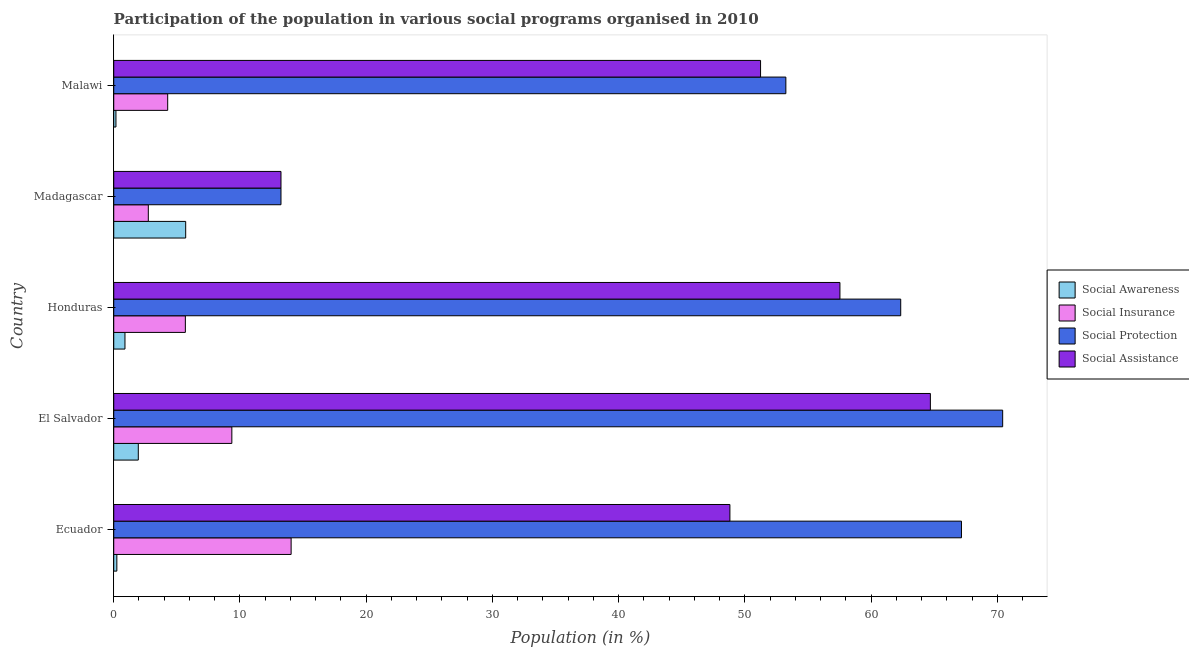How many different coloured bars are there?
Make the answer very short. 4. How many groups of bars are there?
Provide a succinct answer. 5. How many bars are there on the 5th tick from the top?
Offer a terse response. 4. How many bars are there on the 2nd tick from the bottom?
Make the answer very short. 4. What is the label of the 5th group of bars from the top?
Offer a terse response. Ecuador. What is the participation of population in social protection programs in Malawi?
Ensure brevity in your answer.  53.24. Across all countries, what is the maximum participation of population in social awareness programs?
Provide a short and direct response. 5.7. Across all countries, what is the minimum participation of population in social insurance programs?
Your response must be concise. 2.74. In which country was the participation of population in social awareness programs maximum?
Provide a short and direct response. Madagascar. In which country was the participation of population in social protection programs minimum?
Keep it short and to the point. Madagascar. What is the total participation of population in social protection programs in the graph?
Ensure brevity in your answer.  266.4. What is the difference between the participation of population in social protection programs in Ecuador and that in Madagascar?
Your response must be concise. 53.9. What is the difference between the participation of population in social awareness programs in Honduras and the participation of population in social insurance programs in El Salvador?
Your answer should be compact. -8.47. What is the average participation of population in social assistance programs per country?
Provide a succinct answer. 47.1. What is the difference between the participation of population in social awareness programs and participation of population in social protection programs in Malawi?
Offer a very short reply. -53.07. What is the ratio of the participation of population in social assistance programs in Ecuador to that in El Salvador?
Provide a succinct answer. 0.76. Is the difference between the participation of population in social awareness programs in Ecuador and Honduras greater than the difference between the participation of population in social protection programs in Ecuador and Honduras?
Your answer should be compact. No. What is the difference between the highest and the second highest participation of population in social protection programs?
Offer a very short reply. 3.26. What is the difference between the highest and the lowest participation of population in social awareness programs?
Your answer should be compact. 5.52. What does the 4th bar from the top in Honduras represents?
Keep it short and to the point. Social Awareness. What does the 1st bar from the bottom in Ecuador represents?
Provide a short and direct response. Social Awareness. Are all the bars in the graph horizontal?
Keep it short and to the point. Yes. How many countries are there in the graph?
Offer a very short reply. 5. Does the graph contain grids?
Your answer should be compact. No. Where does the legend appear in the graph?
Provide a succinct answer. Center right. How many legend labels are there?
Give a very brief answer. 4. What is the title of the graph?
Provide a short and direct response. Participation of the population in various social programs organised in 2010. Does "UNTA" appear as one of the legend labels in the graph?
Ensure brevity in your answer.  No. What is the label or title of the Y-axis?
Give a very brief answer. Country. What is the Population (in %) in Social Awareness in Ecuador?
Your answer should be compact. 0.25. What is the Population (in %) of Social Insurance in Ecuador?
Your answer should be compact. 14.05. What is the Population (in %) in Social Protection in Ecuador?
Make the answer very short. 67.15. What is the Population (in %) in Social Assistance in Ecuador?
Your response must be concise. 48.81. What is the Population (in %) of Social Awareness in El Salvador?
Your answer should be very brief. 1.95. What is the Population (in %) in Social Insurance in El Salvador?
Your answer should be compact. 9.35. What is the Population (in %) in Social Protection in El Salvador?
Provide a succinct answer. 70.42. What is the Population (in %) in Social Assistance in El Salvador?
Keep it short and to the point. 64.69. What is the Population (in %) of Social Awareness in Honduras?
Your response must be concise. 0.89. What is the Population (in %) in Social Insurance in Honduras?
Provide a short and direct response. 5.67. What is the Population (in %) in Social Protection in Honduras?
Provide a short and direct response. 62.34. What is the Population (in %) of Social Assistance in Honduras?
Your answer should be very brief. 57.53. What is the Population (in %) of Social Awareness in Madagascar?
Provide a short and direct response. 5.7. What is the Population (in %) in Social Insurance in Madagascar?
Ensure brevity in your answer.  2.74. What is the Population (in %) in Social Protection in Madagascar?
Your answer should be very brief. 13.25. What is the Population (in %) of Social Assistance in Madagascar?
Offer a very short reply. 13.25. What is the Population (in %) in Social Awareness in Malawi?
Keep it short and to the point. 0.18. What is the Population (in %) in Social Insurance in Malawi?
Offer a very short reply. 4.27. What is the Population (in %) in Social Protection in Malawi?
Make the answer very short. 53.24. What is the Population (in %) in Social Assistance in Malawi?
Give a very brief answer. 51.24. Across all countries, what is the maximum Population (in %) of Social Awareness?
Your answer should be compact. 5.7. Across all countries, what is the maximum Population (in %) in Social Insurance?
Give a very brief answer. 14.05. Across all countries, what is the maximum Population (in %) in Social Protection?
Your answer should be compact. 70.42. Across all countries, what is the maximum Population (in %) of Social Assistance?
Your answer should be compact. 64.69. Across all countries, what is the minimum Population (in %) in Social Awareness?
Offer a terse response. 0.18. Across all countries, what is the minimum Population (in %) in Social Insurance?
Make the answer very short. 2.74. Across all countries, what is the minimum Population (in %) in Social Protection?
Make the answer very short. 13.25. Across all countries, what is the minimum Population (in %) in Social Assistance?
Keep it short and to the point. 13.25. What is the total Population (in %) of Social Awareness in the graph?
Ensure brevity in your answer.  8.95. What is the total Population (in %) in Social Insurance in the graph?
Give a very brief answer. 36.09. What is the total Population (in %) in Social Protection in the graph?
Your answer should be compact. 266.4. What is the total Population (in %) in Social Assistance in the graph?
Offer a very short reply. 235.51. What is the difference between the Population (in %) in Social Awareness in Ecuador and that in El Salvador?
Make the answer very short. -1.7. What is the difference between the Population (in %) of Social Insurance in Ecuador and that in El Salvador?
Keep it short and to the point. 4.7. What is the difference between the Population (in %) of Social Protection in Ecuador and that in El Salvador?
Your answer should be compact. -3.26. What is the difference between the Population (in %) in Social Assistance in Ecuador and that in El Salvador?
Give a very brief answer. -15.88. What is the difference between the Population (in %) of Social Awareness in Ecuador and that in Honduras?
Offer a very short reply. -0.64. What is the difference between the Population (in %) in Social Insurance in Ecuador and that in Honduras?
Make the answer very short. 8.38. What is the difference between the Population (in %) of Social Protection in Ecuador and that in Honduras?
Your answer should be compact. 4.81. What is the difference between the Population (in %) in Social Assistance in Ecuador and that in Honduras?
Ensure brevity in your answer.  -8.72. What is the difference between the Population (in %) in Social Awareness in Ecuador and that in Madagascar?
Offer a terse response. -5.45. What is the difference between the Population (in %) of Social Insurance in Ecuador and that in Madagascar?
Offer a very short reply. 11.31. What is the difference between the Population (in %) in Social Protection in Ecuador and that in Madagascar?
Keep it short and to the point. 53.9. What is the difference between the Population (in %) in Social Assistance in Ecuador and that in Madagascar?
Make the answer very short. 35.56. What is the difference between the Population (in %) of Social Awareness in Ecuador and that in Malawi?
Your answer should be compact. 0.07. What is the difference between the Population (in %) in Social Insurance in Ecuador and that in Malawi?
Your answer should be compact. 9.78. What is the difference between the Population (in %) in Social Protection in Ecuador and that in Malawi?
Your answer should be very brief. 13.91. What is the difference between the Population (in %) of Social Assistance in Ecuador and that in Malawi?
Provide a succinct answer. -2.43. What is the difference between the Population (in %) in Social Awareness in El Salvador and that in Honduras?
Provide a short and direct response. 1.06. What is the difference between the Population (in %) of Social Insurance in El Salvador and that in Honduras?
Your answer should be compact. 3.68. What is the difference between the Population (in %) of Social Protection in El Salvador and that in Honduras?
Offer a very short reply. 8.08. What is the difference between the Population (in %) of Social Assistance in El Salvador and that in Honduras?
Provide a short and direct response. 7.16. What is the difference between the Population (in %) of Social Awareness in El Salvador and that in Madagascar?
Provide a succinct answer. -3.75. What is the difference between the Population (in %) of Social Insurance in El Salvador and that in Madagascar?
Provide a succinct answer. 6.62. What is the difference between the Population (in %) in Social Protection in El Salvador and that in Madagascar?
Provide a short and direct response. 57.17. What is the difference between the Population (in %) in Social Assistance in El Salvador and that in Madagascar?
Give a very brief answer. 51.44. What is the difference between the Population (in %) in Social Awareness in El Salvador and that in Malawi?
Provide a short and direct response. 1.77. What is the difference between the Population (in %) of Social Insurance in El Salvador and that in Malawi?
Your answer should be very brief. 5.08. What is the difference between the Population (in %) in Social Protection in El Salvador and that in Malawi?
Give a very brief answer. 17.17. What is the difference between the Population (in %) of Social Assistance in El Salvador and that in Malawi?
Your answer should be compact. 13.45. What is the difference between the Population (in %) in Social Awareness in Honduras and that in Madagascar?
Make the answer very short. -4.81. What is the difference between the Population (in %) in Social Insurance in Honduras and that in Madagascar?
Make the answer very short. 2.93. What is the difference between the Population (in %) of Social Protection in Honduras and that in Madagascar?
Offer a terse response. 49.09. What is the difference between the Population (in %) in Social Assistance in Honduras and that in Madagascar?
Provide a short and direct response. 44.28. What is the difference between the Population (in %) in Social Awareness in Honduras and that in Malawi?
Offer a terse response. 0.71. What is the difference between the Population (in %) in Social Insurance in Honduras and that in Malawi?
Give a very brief answer. 1.4. What is the difference between the Population (in %) in Social Protection in Honduras and that in Malawi?
Your response must be concise. 9.1. What is the difference between the Population (in %) of Social Assistance in Honduras and that in Malawi?
Provide a succinct answer. 6.29. What is the difference between the Population (in %) of Social Awareness in Madagascar and that in Malawi?
Your answer should be compact. 5.52. What is the difference between the Population (in %) in Social Insurance in Madagascar and that in Malawi?
Give a very brief answer. -1.53. What is the difference between the Population (in %) of Social Protection in Madagascar and that in Malawi?
Your response must be concise. -39.99. What is the difference between the Population (in %) in Social Assistance in Madagascar and that in Malawi?
Offer a terse response. -37.99. What is the difference between the Population (in %) in Social Awareness in Ecuador and the Population (in %) in Social Insurance in El Salvador?
Offer a terse response. -9.11. What is the difference between the Population (in %) in Social Awareness in Ecuador and the Population (in %) in Social Protection in El Salvador?
Make the answer very short. -70.17. What is the difference between the Population (in %) in Social Awareness in Ecuador and the Population (in %) in Social Assistance in El Salvador?
Provide a succinct answer. -64.44. What is the difference between the Population (in %) in Social Insurance in Ecuador and the Population (in %) in Social Protection in El Salvador?
Offer a very short reply. -56.36. What is the difference between the Population (in %) of Social Insurance in Ecuador and the Population (in %) of Social Assistance in El Salvador?
Provide a short and direct response. -50.64. What is the difference between the Population (in %) of Social Protection in Ecuador and the Population (in %) of Social Assistance in El Salvador?
Offer a very short reply. 2.46. What is the difference between the Population (in %) of Social Awareness in Ecuador and the Population (in %) of Social Insurance in Honduras?
Give a very brief answer. -5.43. What is the difference between the Population (in %) of Social Awareness in Ecuador and the Population (in %) of Social Protection in Honduras?
Offer a very short reply. -62.09. What is the difference between the Population (in %) in Social Awareness in Ecuador and the Population (in %) in Social Assistance in Honduras?
Keep it short and to the point. -57.28. What is the difference between the Population (in %) of Social Insurance in Ecuador and the Population (in %) of Social Protection in Honduras?
Make the answer very short. -48.29. What is the difference between the Population (in %) of Social Insurance in Ecuador and the Population (in %) of Social Assistance in Honduras?
Your answer should be compact. -43.47. What is the difference between the Population (in %) of Social Protection in Ecuador and the Population (in %) of Social Assistance in Honduras?
Provide a succinct answer. 9.63. What is the difference between the Population (in %) in Social Awareness in Ecuador and the Population (in %) in Social Insurance in Madagascar?
Your answer should be compact. -2.49. What is the difference between the Population (in %) in Social Awareness in Ecuador and the Population (in %) in Social Protection in Madagascar?
Provide a succinct answer. -13. What is the difference between the Population (in %) in Social Awareness in Ecuador and the Population (in %) in Social Assistance in Madagascar?
Ensure brevity in your answer.  -13. What is the difference between the Population (in %) of Social Insurance in Ecuador and the Population (in %) of Social Protection in Madagascar?
Your answer should be very brief. 0.8. What is the difference between the Population (in %) in Social Insurance in Ecuador and the Population (in %) in Social Assistance in Madagascar?
Provide a short and direct response. 0.8. What is the difference between the Population (in %) of Social Protection in Ecuador and the Population (in %) of Social Assistance in Madagascar?
Make the answer very short. 53.9. What is the difference between the Population (in %) in Social Awareness in Ecuador and the Population (in %) in Social Insurance in Malawi?
Your response must be concise. -4.03. What is the difference between the Population (in %) of Social Awareness in Ecuador and the Population (in %) of Social Protection in Malawi?
Offer a very short reply. -53. What is the difference between the Population (in %) of Social Awareness in Ecuador and the Population (in %) of Social Assistance in Malawi?
Provide a short and direct response. -50.99. What is the difference between the Population (in %) in Social Insurance in Ecuador and the Population (in %) in Social Protection in Malawi?
Provide a short and direct response. -39.19. What is the difference between the Population (in %) in Social Insurance in Ecuador and the Population (in %) in Social Assistance in Malawi?
Keep it short and to the point. -37.19. What is the difference between the Population (in %) of Social Protection in Ecuador and the Population (in %) of Social Assistance in Malawi?
Ensure brevity in your answer.  15.91. What is the difference between the Population (in %) of Social Awareness in El Salvador and the Population (in %) of Social Insurance in Honduras?
Your response must be concise. -3.73. What is the difference between the Population (in %) of Social Awareness in El Salvador and the Population (in %) of Social Protection in Honduras?
Keep it short and to the point. -60.39. What is the difference between the Population (in %) in Social Awareness in El Salvador and the Population (in %) in Social Assistance in Honduras?
Make the answer very short. -55.58. What is the difference between the Population (in %) in Social Insurance in El Salvador and the Population (in %) in Social Protection in Honduras?
Your answer should be very brief. -52.99. What is the difference between the Population (in %) in Social Insurance in El Salvador and the Population (in %) in Social Assistance in Honduras?
Keep it short and to the point. -48.17. What is the difference between the Population (in %) of Social Protection in El Salvador and the Population (in %) of Social Assistance in Honduras?
Offer a terse response. 12.89. What is the difference between the Population (in %) in Social Awareness in El Salvador and the Population (in %) in Social Insurance in Madagascar?
Ensure brevity in your answer.  -0.79. What is the difference between the Population (in %) in Social Awareness in El Salvador and the Population (in %) in Social Protection in Madagascar?
Provide a short and direct response. -11.3. What is the difference between the Population (in %) in Social Awareness in El Salvador and the Population (in %) in Social Assistance in Madagascar?
Your answer should be very brief. -11.3. What is the difference between the Population (in %) of Social Insurance in El Salvador and the Population (in %) of Social Protection in Madagascar?
Your answer should be very brief. -3.89. What is the difference between the Population (in %) in Social Insurance in El Salvador and the Population (in %) in Social Assistance in Madagascar?
Offer a very short reply. -3.89. What is the difference between the Population (in %) of Social Protection in El Salvador and the Population (in %) of Social Assistance in Madagascar?
Provide a short and direct response. 57.17. What is the difference between the Population (in %) in Social Awareness in El Salvador and the Population (in %) in Social Insurance in Malawi?
Make the answer very short. -2.33. What is the difference between the Population (in %) of Social Awareness in El Salvador and the Population (in %) of Social Protection in Malawi?
Ensure brevity in your answer.  -51.3. What is the difference between the Population (in %) of Social Awareness in El Salvador and the Population (in %) of Social Assistance in Malawi?
Offer a very short reply. -49.29. What is the difference between the Population (in %) of Social Insurance in El Salvador and the Population (in %) of Social Protection in Malawi?
Your answer should be very brief. -43.89. What is the difference between the Population (in %) in Social Insurance in El Salvador and the Population (in %) in Social Assistance in Malawi?
Make the answer very short. -41.88. What is the difference between the Population (in %) of Social Protection in El Salvador and the Population (in %) of Social Assistance in Malawi?
Your answer should be compact. 19.18. What is the difference between the Population (in %) of Social Awareness in Honduras and the Population (in %) of Social Insurance in Madagascar?
Make the answer very short. -1.85. What is the difference between the Population (in %) of Social Awareness in Honduras and the Population (in %) of Social Protection in Madagascar?
Give a very brief answer. -12.36. What is the difference between the Population (in %) in Social Awareness in Honduras and the Population (in %) in Social Assistance in Madagascar?
Your answer should be very brief. -12.36. What is the difference between the Population (in %) in Social Insurance in Honduras and the Population (in %) in Social Protection in Madagascar?
Your response must be concise. -7.57. What is the difference between the Population (in %) of Social Insurance in Honduras and the Population (in %) of Social Assistance in Madagascar?
Your response must be concise. -7.57. What is the difference between the Population (in %) of Social Protection in Honduras and the Population (in %) of Social Assistance in Madagascar?
Provide a short and direct response. 49.09. What is the difference between the Population (in %) of Social Awareness in Honduras and the Population (in %) of Social Insurance in Malawi?
Offer a very short reply. -3.38. What is the difference between the Population (in %) in Social Awareness in Honduras and the Population (in %) in Social Protection in Malawi?
Your response must be concise. -52.35. What is the difference between the Population (in %) of Social Awareness in Honduras and the Population (in %) of Social Assistance in Malawi?
Provide a short and direct response. -50.35. What is the difference between the Population (in %) of Social Insurance in Honduras and the Population (in %) of Social Protection in Malawi?
Provide a short and direct response. -47.57. What is the difference between the Population (in %) of Social Insurance in Honduras and the Population (in %) of Social Assistance in Malawi?
Provide a succinct answer. -45.57. What is the difference between the Population (in %) of Social Protection in Honduras and the Population (in %) of Social Assistance in Malawi?
Your answer should be very brief. 11.1. What is the difference between the Population (in %) in Social Awareness in Madagascar and the Population (in %) in Social Insurance in Malawi?
Your answer should be very brief. 1.43. What is the difference between the Population (in %) of Social Awareness in Madagascar and the Population (in %) of Social Protection in Malawi?
Offer a very short reply. -47.54. What is the difference between the Population (in %) of Social Awareness in Madagascar and the Population (in %) of Social Assistance in Malawi?
Your response must be concise. -45.54. What is the difference between the Population (in %) in Social Insurance in Madagascar and the Population (in %) in Social Protection in Malawi?
Your response must be concise. -50.5. What is the difference between the Population (in %) in Social Insurance in Madagascar and the Population (in %) in Social Assistance in Malawi?
Keep it short and to the point. -48.5. What is the difference between the Population (in %) in Social Protection in Madagascar and the Population (in %) in Social Assistance in Malawi?
Provide a succinct answer. -37.99. What is the average Population (in %) in Social Awareness per country?
Your answer should be compact. 1.79. What is the average Population (in %) in Social Insurance per country?
Ensure brevity in your answer.  7.22. What is the average Population (in %) of Social Protection per country?
Your response must be concise. 53.28. What is the average Population (in %) of Social Assistance per country?
Your answer should be compact. 47.1. What is the difference between the Population (in %) of Social Awareness and Population (in %) of Social Insurance in Ecuador?
Keep it short and to the point. -13.81. What is the difference between the Population (in %) in Social Awareness and Population (in %) in Social Protection in Ecuador?
Provide a short and direct response. -66.91. What is the difference between the Population (in %) in Social Awareness and Population (in %) in Social Assistance in Ecuador?
Offer a terse response. -48.56. What is the difference between the Population (in %) in Social Insurance and Population (in %) in Social Protection in Ecuador?
Provide a succinct answer. -53.1. What is the difference between the Population (in %) in Social Insurance and Population (in %) in Social Assistance in Ecuador?
Keep it short and to the point. -34.76. What is the difference between the Population (in %) in Social Protection and Population (in %) in Social Assistance in Ecuador?
Provide a short and direct response. 18.34. What is the difference between the Population (in %) of Social Awareness and Population (in %) of Social Insurance in El Salvador?
Ensure brevity in your answer.  -7.41. What is the difference between the Population (in %) in Social Awareness and Population (in %) in Social Protection in El Salvador?
Make the answer very short. -68.47. What is the difference between the Population (in %) of Social Awareness and Population (in %) of Social Assistance in El Salvador?
Offer a terse response. -62.74. What is the difference between the Population (in %) in Social Insurance and Population (in %) in Social Protection in El Salvador?
Offer a very short reply. -61.06. What is the difference between the Population (in %) of Social Insurance and Population (in %) of Social Assistance in El Salvador?
Your answer should be compact. -55.33. What is the difference between the Population (in %) in Social Protection and Population (in %) in Social Assistance in El Salvador?
Provide a short and direct response. 5.73. What is the difference between the Population (in %) of Social Awareness and Population (in %) of Social Insurance in Honduras?
Your answer should be compact. -4.78. What is the difference between the Population (in %) in Social Awareness and Population (in %) in Social Protection in Honduras?
Provide a short and direct response. -61.45. What is the difference between the Population (in %) in Social Awareness and Population (in %) in Social Assistance in Honduras?
Your response must be concise. -56.64. What is the difference between the Population (in %) of Social Insurance and Population (in %) of Social Protection in Honduras?
Give a very brief answer. -56.67. What is the difference between the Population (in %) in Social Insurance and Population (in %) in Social Assistance in Honduras?
Offer a terse response. -51.85. What is the difference between the Population (in %) in Social Protection and Population (in %) in Social Assistance in Honduras?
Ensure brevity in your answer.  4.82. What is the difference between the Population (in %) in Social Awareness and Population (in %) in Social Insurance in Madagascar?
Ensure brevity in your answer.  2.96. What is the difference between the Population (in %) of Social Awareness and Population (in %) of Social Protection in Madagascar?
Ensure brevity in your answer.  -7.55. What is the difference between the Population (in %) of Social Awareness and Population (in %) of Social Assistance in Madagascar?
Give a very brief answer. -7.55. What is the difference between the Population (in %) in Social Insurance and Population (in %) in Social Protection in Madagascar?
Keep it short and to the point. -10.51. What is the difference between the Population (in %) of Social Insurance and Population (in %) of Social Assistance in Madagascar?
Your response must be concise. -10.51. What is the difference between the Population (in %) of Social Awareness and Population (in %) of Social Insurance in Malawi?
Your response must be concise. -4.1. What is the difference between the Population (in %) of Social Awareness and Population (in %) of Social Protection in Malawi?
Give a very brief answer. -53.07. What is the difference between the Population (in %) in Social Awareness and Population (in %) in Social Assistance in Malawi?
Provide a short and direct response. -51.06. What is the difference between the Population (in %) in Social Insurance and Population (in %) in Social Protection in Malawi?
Provide a succinct answer. -48.97. What is the difference between the Population (in %) of Social Insurance and Population (in %) of Social Assistance in Malawi?
Your answer should be very brief. -46.96. What is the difference between the Population (in %) of Social Protection and Population (in %) of Social Assistance in Malawi?
Give a very brief answer. 2. What is the ratio of the Population (in %) in Social Awareness in Ecuador to that in El Salvador?
Your answer should be compact. 0.13. What is the ratio of the Population (in %) in Social Insurance in Ecuador to that in El Salvador?
Offer a very short reply. 1.5. What is the ratio of the Population (in %) in Social Protection in Ecuador to that in El Salvador?
Your answer should be compact. 0.95. What is the ratio of the Population (in %) in Social Assistance in Ecuador to that in El Salvador?
Keep it short and to the point. 0.75. What is the ratio of the Population (in %) in Social Awareness in Ecuador to that in Honduras?
Your answer should be compact. 0.28. What is the ratio of the Population (in %) of Social Insurance in Ecuador to that in Honduras?
Your answer should be compact. 2.48. What is the ratio of the Population (in %) in Social Protection in Ecuador to that in Honduras?
Give a very brief answer. 1.08. What is the ratio of the Population (in %) of Social Assistance in Ecuador to that in Honduras?
Provide a succinct answer. 0.85. What is the ratio of the Population (in %) of Social Awareness in Ecuador to that in Madagascar?
Make the answer very short. 0.04. What is the ratio of the Population (in %) of Social Insurance in Ecuador to that in Madagascar?
Your answer should be compact. 5.13. What is the ratio of the Population (in %) of Social Protection in Ecuador to that in Madagascar?
Provide a short and direct response. 5.07. What is the ratio of the Population (in %) of Social Assistance in Ecuador to that in Madagascar?
Provide a succinct answer. 3.68. What is the ratio of the Population (in %) in Social Awareness in Ecuador to that in Malawi?
Offer a terse response. 1.4. What is the ratio of the Population (in %) of Social Insurance in Ecuador to that in Malawi?
Offer a terse response. 3.29. What is the ratio of the Population (in %) of Social Protection in Ecuador to that in Malawi?
Give a very brief answer. 1.26. What is the ratio of the Population (in %) in Social Assistance in Ecuador to that in Malawi?
Offer a very short reply. 0.95. What is the ratio of the Population (in %) in Social Awareness in El Salvador to that in Honduras?
Keep it short and to the point. 2.19. What is the ratio of the Population (in %) of Social Insurance in El Salvador to that in Honduras?
Your answer should be compact. 1.65. What is the ratio of the Population (in %) of Social Protection in El Salvador to that in Honduras?
Your answer should be very brief. 1.13. What is the ratio of the Population (in %) in Social Assistance in El Salvador to that in Honduras?
Provide a short and direct response. 1.12. What is the ratio of the Population (in %) in Social Awareness in El Salvador to that in Madagascar?
Your response must be concise. 0.34. What is the ratio of the Population (in %) of Social Insurance in El Salvador to that in Madagascar?
Make the answer very short. 3.42. What is the ratio of the Population (in %) in Social Protection in El Salvador to that in Madagascar?
Offer a terse response. 5.32. What is the ratio of the Population (in %) of Social Assistance in El Salvador to that in Madagascar?
Give a very brief answer. 4.88. What is the ratio of the Population (in %) in Social Awareness in El Salvador to that in Malawi?
Make the answer very short. 11.11. What is the ratio of the Population (in %) of Social Insurance in El Salvador to that in Malawi?
Your response must be concise. 2.19. What is the ratio of the Population (in %) in Social Protection in El Salvador to that in Malawi?
Ensure brevity in your answer.  1.32. What is the ratio of the Population (in %) of Social Assistance in El Salvador to that in Malawi?
Keep it short and to the point. 1.26. What is the ratio of the Population (in %) in Social Awareness in Honduras to that in Madagascar?
Provide a succinct answer. 0.16. What is the ratio of the Population (in %) in Social Insurance in Honduras to that in Madagascar?
Ensure brevity in your answer.  2.07. What is the ratio of the Population (in %) of Social Protection in Honduras to that in Madagascar?
Keep it short and to the point. 4.71. What is the ratio of the Population (in %) of Social Assistance in Honduras to that in Madagascar?
Ensure brevity in your answer.  4.34. What is the ratio of the Population (in %) in Social Awareness in Honduras to that in Malawi?
Your answer should be very brief. 5.08. What is the ratio of the Population (in %) in Social Insurance in Honduras to that in Malawi?
Ensure brevity in your answer.  1.33. What is the ratio of the Population (in %) in Social Protection in Honduras to that in Malawi?
Make the answer very short. 1.17. What is the ratio of the Population (in %) in Social Assistance in Honduras to that in Malawi?
Offer a terse response. 1.12. What is the ratio of the Population (in %) in Social Awareness in Madagascar to that in Malawi?
Make the answer very short. 32.55. What is the ratio of the Population (in %) of Social Insurance in Madagascar to that in Malawi?
Keep it short and to the point. 0.64. What is the ratio of the Population (in %) in Social Protection in Madagascar to that in Malawi?
Your response must be concise. 0.25. What is the ratio of the Population (in %) in Social Assistance in Madagascar to that in Malawi?
Provide a short and direct response. 0.26. What is the difference between the highest and the second highest Population (in %) in Social Awareness?
Ensure brevity in your answer.  3.75. What is the difference between the highest and the second highest Population (in %) of Social Insurance?
Offer a terse response. 4.7. What is the difference between the highest and the second highest Population (in %) in Social Protection?
Your answer should be compact. 3.26. What is the difference between the highest and the second highest Population (in %) in Social Assistance?
Ensure brevity in your answer.  7.16. What is the difference between the highest and the lowest Population (in %) in Social Awareness?
Your answer should be compact. 5.52. What is the difference between the highest and the lowest Population (in %) in Social Insurance?
Make the answer very short. 11.31. What is the difference between the highest and the lowest Population (in %) of Social Protection?
Offer a terse response. 57.17. What is the difference between the highest and the lowest Population (in %) of Social Assistance?
Make the answer very short. 51.44. 